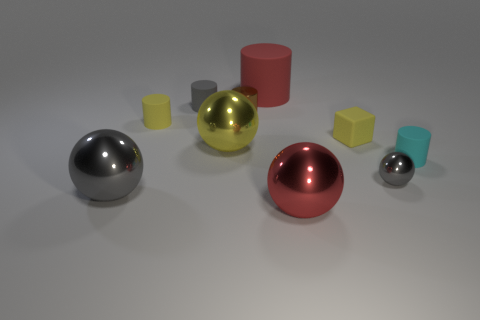There is a red shiny object that is in front of the tiny brown thing; is it the same shape as the tiny brown metal object?
Your answer should be very brief. No. What number of other things have the same shape as the small brown metallic thing?
Offer a terse response. 4. Are there any red spheres made of the same material as the gray cylinder?
Offer a terse response. No. What material is the gray thing that is behind the yellow rubber thing left of the brown cylinder made of?
Offer a terse response. Rubber. How big is the yellow thing on the right side of the brown cylinder?
Give a very brief answer. Small. There is a small matte cube; is it the same color as the large cylinder that is on the left side of the tiny gray shiny thing?
Your response must be concise. No. Is there a large ball of the same color as the metal cylinder?
Offer a very short reply. No. Does the block have the same material as the big yellow thing to the left of the big red matte cylinder?
Ensure brevity in your answer.  No. What number of big things are yellow metallic balls or matte things?
Offer a terse response. 2. There is a object that is the same color as the big cylinder; what material is it?
Your answer should be compact. Metal. 